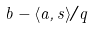<formula> <loc_0><loc_0><loc_500><loc_500>b - \langle a , s \rangle / q</formula> 